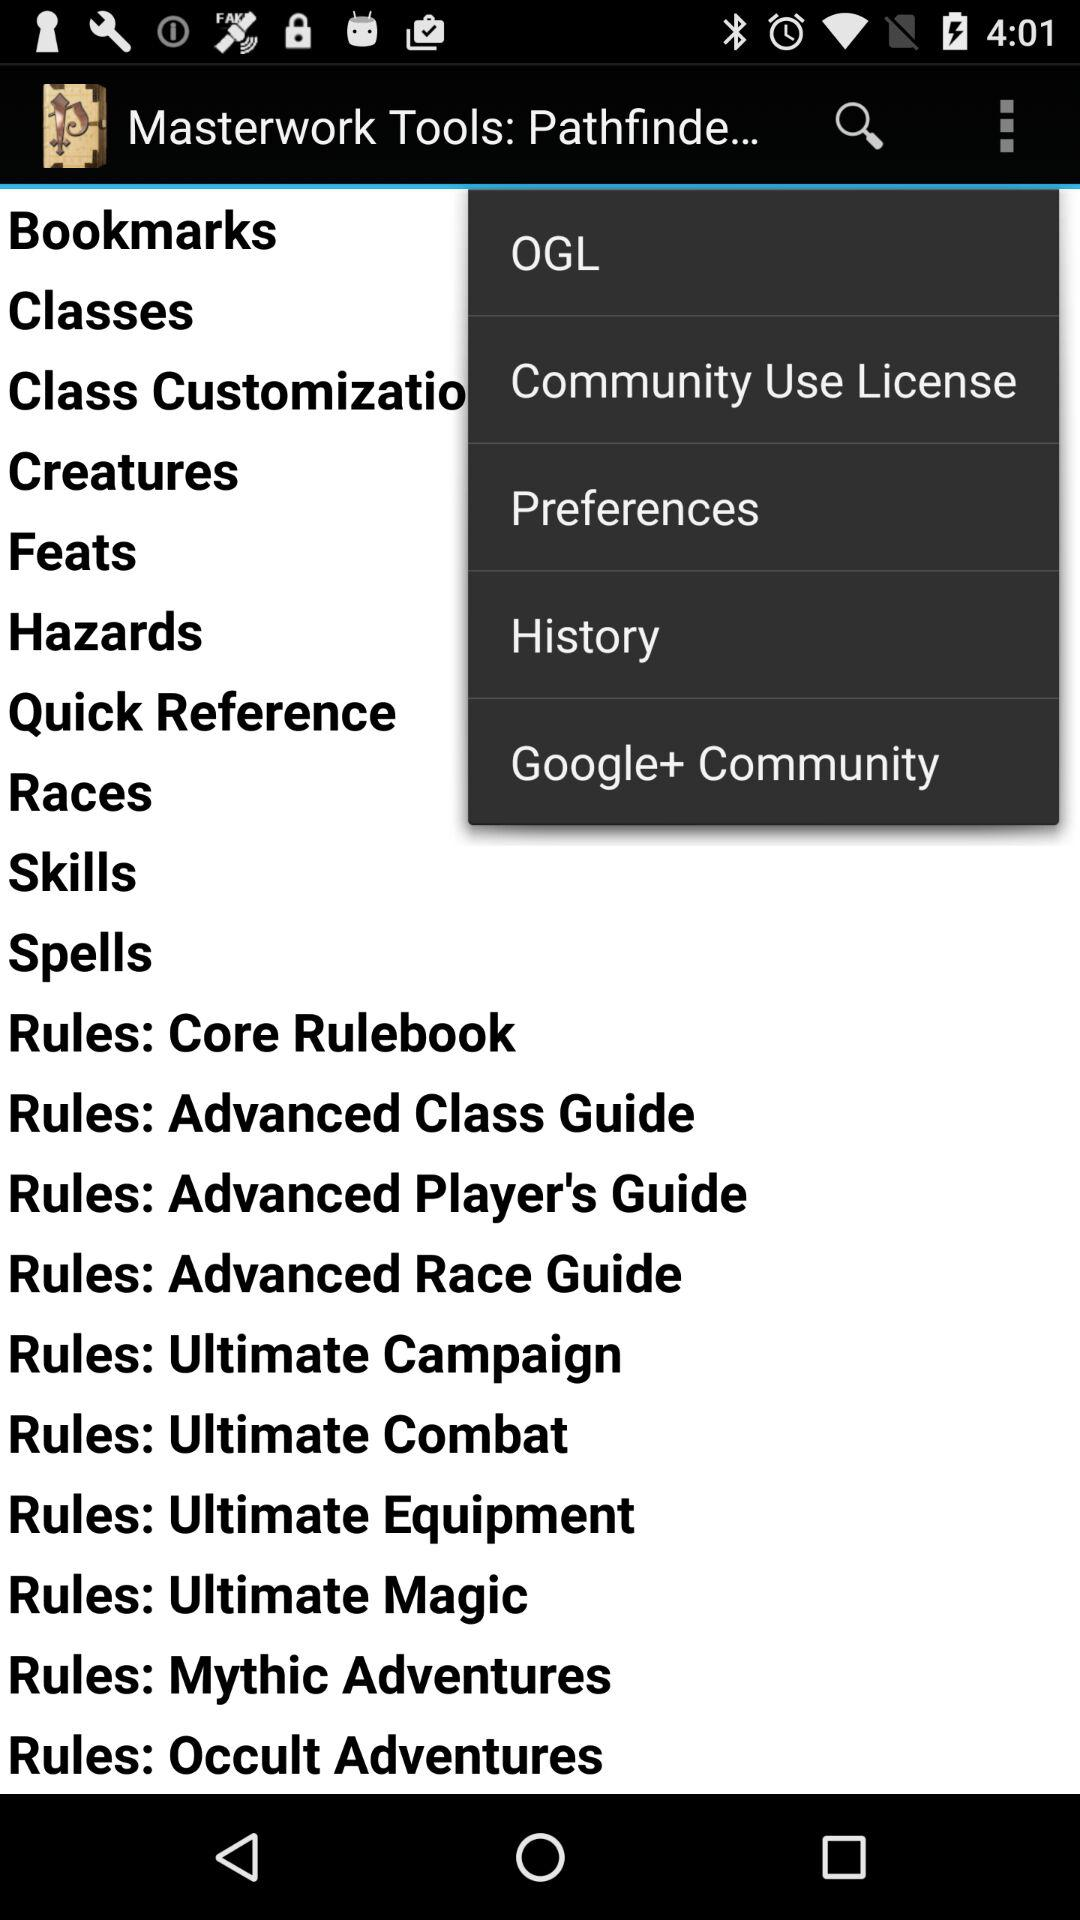What is the application name? The application name is "Masterwork Tools: Pathfinde...". 